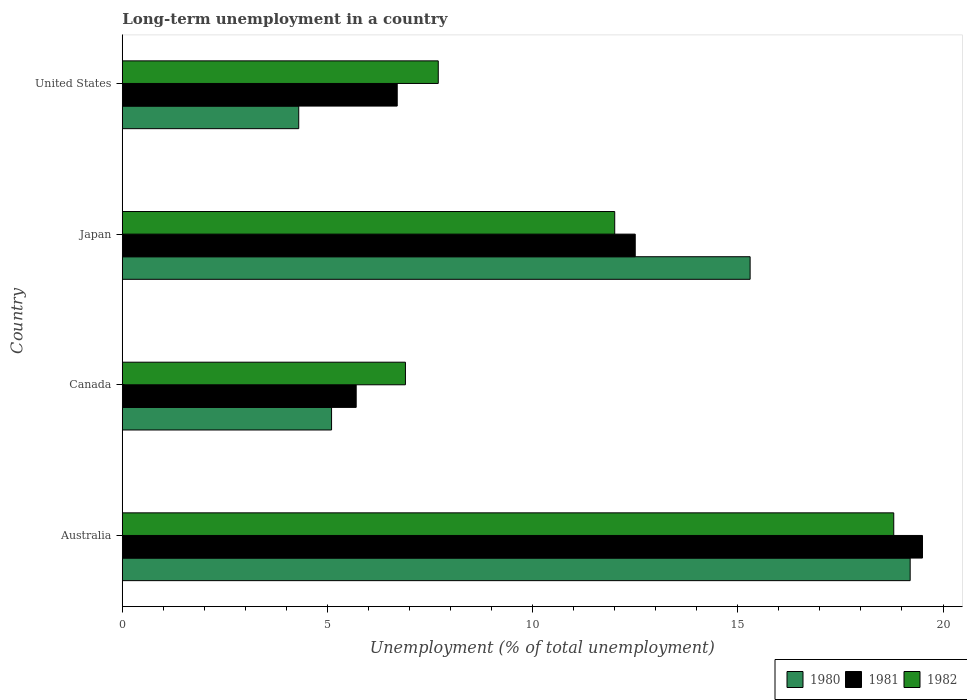How many different coloured bars are there?
Give a very brief answer. 3. How many bars are there on the 4th tick from the top?
Your answer should be very brief. 3. In how many cases, is the number of bars for a given country not equal to the number of legend labels?
Give a very brief answer. 0. What is the percentage of long-term unemployed population in 1980 in Japan?
Provide a short and direct response. 15.3. Across all countries, what is the maximum percentage of long-term unemployed population in 1980?
Offer a very short reply. 19.2. Across all countries, what is the minimum percentage of long-term unemployed population in 1982?
Ensure brevity in your answer.  6.9. In which country was the percentage of long-term unemployed population in 1982 minimum?
Make the answer very short. Canada. What is the total percentage of long-term unemployed population in 1981 in the graph?
Your answer should be very brief. 44.4. What is the difference between the percentage of long-term unemployed population in 1982 in Japan and that in United States?
Provide a short and direct response. 4.3. What is the difference between the percentage of long-term unemployed population in 1980 in Japan and the percentage of long-term unemployed population in 1982 in Canada?
Keep it short and to the point. 8.4. What is the average percentage of long-term unemployed population in 1982 per country?
Provide a short and direct response. 11.35. What is the difference between the percentage of long-term unemployed population in 1982 and percentage of long-term unemployed population in 1981 in Japan?
Your response must be concise. -0.5. What is the ratio of the percentage of long-term unemployed population in 1980 in Australia to that in United States?
Provide a short and direct response. 4.47. Is the difference between the percentage of long-term unemployed population in 1982 in Japan and United States greater than the difference between the percentage of long-term unemployed population in 1981 in Japan and United States?
Your answer should be very brief. No. What is the difference between the highest and the second highest percentage of long-term unemployed population in 1980?
Ensure brevity in your answer.  3.9. What is the difference between the highest and the lowest percentage of long-term unemployed population in 1981?
Offer a terse response. 13.8. In how many countries, is the percentage of long-term unemployed population in 1980 greater than the average percentage of long-term unemployed population in 1980 taken over all countries?
Give a very brief answer. 2. Is the sum of the percentage of long-term unemployed population in 1982 in Australia and United States greater than the maximum percentage of long-term unemployed population in 1980 across all countries?
Provide a short and direct response. Yes. Is it the case that in every country, the sum of the percentage of long-term unemployed population in 1981 and percentage of long-term unemployed population in 1980 is greater than the percentage of long-term unemployed population in 1982?
Provide a short and direct response. Yes. How many bars are there?
Provide a short and direct response. 12. Are all the bars in the graph horizontal?
Provide a short and direct response. Yes. How many countries are there in the graph?
Offer a very short reply. 4. What is the difference between two consecutive major ticks on the X-axis?
Your answer should be very brief. 5. Does the graph contain any zero values?
Give a very brief answer. No. How are the legend labels stacked?
Make the answer very short. Horizontal. What is the title of the graph?
Offer a terse response. Long-term unemployment in a country. What is the label or title of the X-axis?
Provide a short and direct response. Unemployment (% of total unemployment). What is the label or title of the Y-axis?
Ensure brevity in your answer.  Country. What is the Unemployment (% of total unemployment) in 1980 in Australia?
Ensure brevity in your answer.  19.2. What is the Unemployment (% of total unemployment) of 1981 in Australia?
Keep it short and to the point. 19.5. What is the Unemployment (% of total unemployment) in 1982 in Australia?
Offer a terse response. 18.8. What is the Unemployment (% of total unemployment) in 1980 in Canada?
Provide a succinct answer. 5.1. What is the Unemployment (% of total unemployment) in 1981 in Canada?
Ensure brevity in your answer.  5.7. What is the Unemployment (% of total unemployment) in 1982 in Canada?
Ensure brevity in your answer.  6.9. What is the Unemployment (% of total unemployment) of 1980 in Japan?
Provide a succinct answer. 15.3. What is the Unemployment (% of total unemployment) of 1981 in Japan?
Your answer should be compact. 12.5. What is the Unemployment (% of total unemployment) in 1982 in Japan?
Offer a terse response. 12. What is the Unemployment (% of total unemployment) in 1980 in United States?
Your response must be concise. 4.3. What is the Unemployment (% of total unemployment) in 1981 in United States?
Provide a succinct answer. 6.7. What is the Unemployment (% of total unemployment) in 1982 in United States?
Provide a short and direct response. 7.7. Across all countries, what is the maximum Unemployment (% of total unemployment) of 1980?
Offer a terse response. 19.2. Across all countries, what is the maximum Unemployment (% of total unemployment) in 1981?
Provide a succinct answer. 19.5. Across all countries, what is the maximum Unemployment (% of total unemployment) of 1982?
Ensure brevity in your answer.  18.8. Across all countries, what is the minimum Unemployment (% of total unemployment) of 1980?
Provide a succinct answer. 4.3. Across all countries, what is the minimum Unemployment (% of total unemployment) in 1981?
Your answer should be very brief. 5.7. Across all countries, what is the minimum Unemployment (% of total unemployment) of 1982?
Offer a very short reply. 6.9. What is the total Unemployment (% of total unemployment) in 1980 in the graph?
Your response must be concise. 43.9. What is the total Unemployment (% of total unemployment) of 1981 in the graph?
Ensure brevity in your answer.  44.4. What is the total Unemployment (% of total unemployment) in 1982 in the graph?
Keep it short and to the point. 45.4. What is the difference between the Unemployment (% of total unemployment) in 1980 in Australia and that in Canada?
Offer a very short reply. 14.1. What is the difference between the Unemployment (% of total unemployment) of 1981 in Australia and that in Canada?
Make the answer very short. 13.8. What is the difference between the Unemployment (% of total unemployment) in 1982 in Australia and that in Canada?
Make the answer very short. 11.9. What is the difference between the Unemployment (% of total unemployment) in 1981 in Australia and that in Japan?
Provide a succinct answer. 7. What is the difference between the Unemployment (% of total unemployment) in 1982 in Australia and that in Japan?
Offer a very short reply. 6.8. What is the difference between the Unemployment (% of total unemployment) in 1981 in Australia and that in United States?
Your answer should be very brief. 12.8. What is the difference between the Unemployment (% of total unemployment) in 1980 in Canada and that in Japan?
Your answer should be very brief. -10.2. What is the difference between the Unemployment (% of total unemployment) in 1982 in Canada and that in Japan?
Give a very brief answer. -5.1. What is the difference between the Unemployment (% of total unemployment) of 1981 in Canada and that in United States?
Provide a short and direct response. -1. What is the difference between the Unemployment (% of total unemployment) in 1982 in Canada and that in United States?
Keep it short and to the point. -0.8. What is the difference between the Unemployment (% of total unemployment) of 1981 in Japan and that in United States?
Your answer should be compact. 5.8. What is the difference between the Unemployment (% of total unemployment) in 1982 in Japan and that in United States?
Make the answer very short. 4.3. What is the difference between the Unemployment (% of total unemployment) of 1980 in Australia and the Unemployment (% of total unemployment) of 1982 in Canada?
Offer a terse response. 12.3. What is the difference between the Unemployment (% of total unemployment) of 1981 in Australia and the Unemployment (% of total unemployment) of 1982 in Canada?
Provide a short and direct response. 12.6. What is the difference between the Unemployment (% of total unemployment) of 1981 in Australia and the Unemployment (% of total unemployment) of 1982 in Japan?
Provide a succinct answer. 7.5. What is the difference between the Unemployment (% of total unemployment) in 1980 in Canada and the Unemployment (% of total unemployment) in 1982 in Japan?
Provide a short and direct response. -6.9. What is the difference between the Unemployment (% of total unemployment) of 1981 in Canada and the Unemployment (% of total unemployment) of 1982 in Japan?
Give a very brief answer. -6.3. What is the difference between the Unemployment (% of total unemployment) in 1981 in Canada and the Unemployment (% of total unemployment) in 1982 in United States?
Provide a succinct answer. -2. What is the difference between the Unemployment (% of total unemployment) of 1980 in Japan and the Unemployment (% of total unemployment) of 1981 in United States?
Provide a short and direct response. 8.6. What is the difference between the Unemployment (% of total unemployment) in 1980 in Japan and the Unemployment (% of total unemployment) in 1982 in United States?
Provide a short and direct response. 7.6. What is the average Unemployment (% of total unemployment) in 1980 per country?
Provide a short and direct response. 10.97. What is the average Unemployment (% of total unemployment) in 1982 per country?
Provide a short and direct response. 11.35. What is the difference between the Unemployment (% of total unemployment) in 1980 and Unemployment (% of total unemployment) in 1982 in Australia?
Your answer should be very brief. 0.4. What is the difference between the Unemployment (% of total unemployment) of 1980 and Unemployment (% of total unemployment) of 1981 in Canada?
Your answer should be compact. -0.6. What is the difference between the Unemployment (% of total unemployment) of 1980 and Unemployment (% of total unemployment) of 1982 in Canada?
Your response must be concise. -1.8. What is the difference between the Unemployment (% of total unemployment) in 1980 and Unemployment (% of total unemployment) in 1981 in Japan?
Provide a succinct answer. 2.8. What is the difference between the Unemployment (% of total unemployment) in 1980 and Unemployment (% of total unemployment) in 1982 in Japan?
Keep it short and to the point. 3.3. What is the difference between the Unemployment (% of total unemployment) in 1981 and Unemployment (% of total unemployment) in 1982 in United States?
Your answer should be very brief. -1. What is the ratio of the Unemployment (% of total unemployment) of 1980 in Australia to that in Canada?
Make the answer very short. 3.76. What is the ratio of the Unemployment (% of total unemployment) of 1981 in Australia to that in Canada?
Provide a short and direct response. 3.42. What is the ratio of the Unemployment (% of total unemployment) of 1982 in Australia to that in Canada?
Your answer should be compact. 2.72. What is the ratio of the Unemployment (% of total unemployment) in 1980 in Australia to that in Japan?
Offer a terse response. 1.25. What is the ratio of the Unemployment (% of total unemployment) of 1981 in Australia to that in Japan?
Your answer should be very brief. 1.56. What is the ratio of the Unemployment (% of total unemployment) in 1982 in Australia to that in Japan?
Your answer should be compact. 1.57. What is the ratio of the Unemployment (% of total unemployment) of 1980 in Australia to that in United States?
Your response must be concise. 4.47. What is the ratio of the Unemployment (% of total unemployment) of 1981 in Australia to that in United States?
Keep it short and to the point. 2.91. What is the ratio of the Unemployment (% of total unemployment) of 1982 in Australia to that in United States?
Make the answer very short. 2.44. What is the ratio of the Unemployment (% of total unemployment) of 1981 in Canada to that in Japan?
Offer a terse response. 0.46. What is the ratio of the Unemployment (% of total unemployment) in 1982 in Canada to that in Japan?
Keep it short and to the point. 0.57. What is the ratio of the Unemployment (% of total unemployment) of 1980 in Canada to that in United States?
Offer a very short reply. 1.19. What is the ratio of the Unemployment (% of total unemployment) in 1981 in Canada to that in United States?
Provide a short and direct response. 0.85. What is the ratio of the Unemployment (% of total unemployment) in 1982 in Canada to that in United States?
Your answer should be very brief. 0.9. What is the ratio of the Unemployment (% of total unemployment) in 1980 in Japan to that in United States?
Give a very brief answer. 3.56. What is the ratio of the Unemployment (% of total unemployment) of 1981 in Japan to that in United States?
Ensure brevity in your answer.  1.87. What is the ratio of the Unemployment (% of total unemployment) of 1982 in Japan to that in United States?
Ensure brevity in your answer.  1.56. What is the difference between the highest and the lowest Unemployment (% of total unemployment) in 1980?
Make the answer very short. 14.9. What is the difference between the highest and the lowest Unemployment (% of total unemployment) in 1982?
Provide a short and direct response. 11.9. 